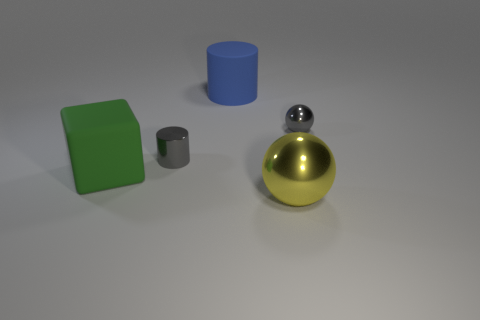Add 4 tiny gray spheres. How many objects exist? 9 Subtract all blocks. How many objects are left? 4 Add 2 tiny gray metal objects. How many tiny gray metal objects exist? 4 Subtract 0 green balls. How many objects are left? 5 Subtract all blue shiny cylinders. Subtract all tiny gray metallic balls. How many objects are left? 4 Add 4 gray spheres. How many gray spheres are left? 5 